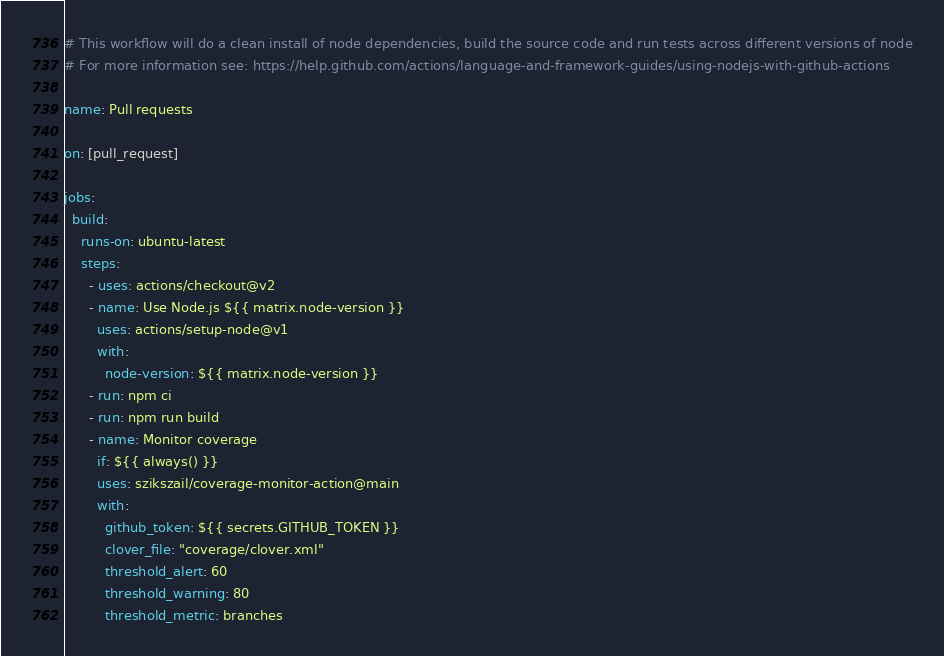<code> <loc_0><loc_0><loc_500><loc_500><_YAML_># This workflow will do a clean install of node dependencies, build the source code and run tests across different versions of node
# For more information see: https://help.github.com/actions/language-and-framework-guides/using-nodejs-with-github-actions

name: Pull requests

on: [pull_request]

jobs:
  build:
    runs-on: ubuntu-latest
    steps:
      - uses: actions/checkout@v2
      - name: Use Node.js ${{ matrix.node-version }}
        uses: actions/setup-node@v1
        with:
          node-version: ${{ matrix.node-version }}
      - run: npm ci
      - run: npm run build
      - name: Monitor coverage
        if: ${{ always() }}
        uses: szikszail/coverage-monitor-action@main
        with:
          github_token: ${{ secrets.GITHUB_TOKEN }}
          clover_file: "coverage/clover.xml"
          threshold_alert: 60
          threshold_warning: 80
          threshold_metric: branches</code> 